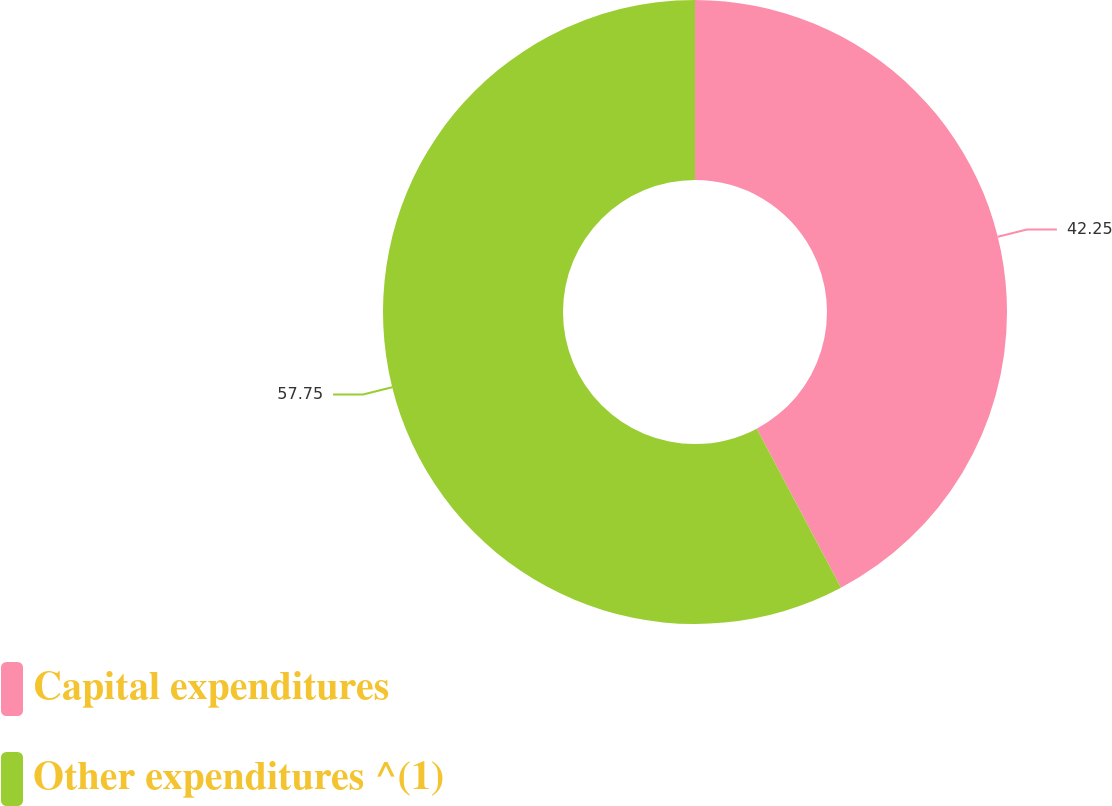Convert chart to OTSL. <chart><loc_0><loc_0><loc_500><loc_500><pie_chart><fcel>Capital expenditures<fcel>Other expenditures ^(1)<nl><fcel>42.25%<fcel>57.75%<nl></chart> 